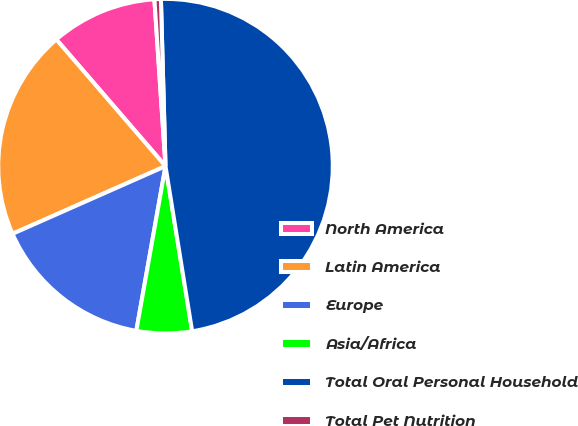Convert chart. <chart><loc_0><loc_0><loc_500><loc_500><pie_chart><fcel>North America<fcel>Latin America<fcel>Europe<fcel>Asia/Africa<fcel>Total Oral Personal Household<fcel>Total Pet Nutrition<nl><fcel>10.26%<fcel>20.31%<fcel>15.58%<fcel>5.34%<fcel>47.89%<fcel>0.62%<nl></chart> 